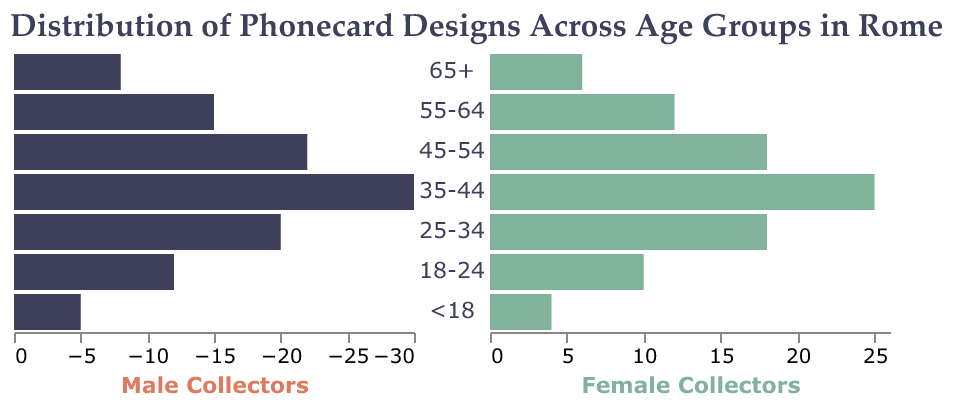What is the age group with the highest number of male collectors? Look at the bar lengths for male collectors (left side) and identify the age group with the longest bar. The 35-44 age group has the longest bar, representing the highest number of male collectors.
Answer: 35-44 Which age group has an equal number of female and male collectors? Compare the bars' lengths of male and female collectors (left and right sides) for each age group. The bars for the 25-34 age group are equal in length.
Answer: 25-34 What is the total number of collectors in the 45-54 age group? Add the number of male collectors (22) to the number of female collectors (18) in the 45-54 age group: 22 + 18 = 40.
Answer: 40 Which age group has the least number of male collectors? Find the age group with the shortest bar on the left side. The <18 age group has the shortest bar for male collectors.
Answer: <18 How many more male collectors are there in the 35-44 age group compared to the 55-64 age group? Subtract the number of male collectors in the 55-64 age group (15) from the number in the 35-44 age group (30): 30 - 15 = 15.
Answer: 15 What is the proportion of female collectors to total collectors in the 65+ age group? Calculate the proportion by dividing the number of female collectors (6) by the total number of collectors in the 65+ age group (8 males + 6 females = 14): 6 / 14 ≈ 0.43.
Answer: 0.43 Which age group has the highest discrepancy between male and female collectors? Find the difference between male and female collectors for each age group and identify the one with the largest difference. The 35-44 age group has the highest discrepancy: 30 males - 25 females = 5.
Answer: 35-44 What is the average number of female collectors across all age groups? Sum the number of female collectors across all age groups (6 + 12 + 18 + 25 + 18 + 10 + 4 = 93) and divide by the number of age groups (7): 93 / 7 ≈ 13.29.
Answer: 13.29 